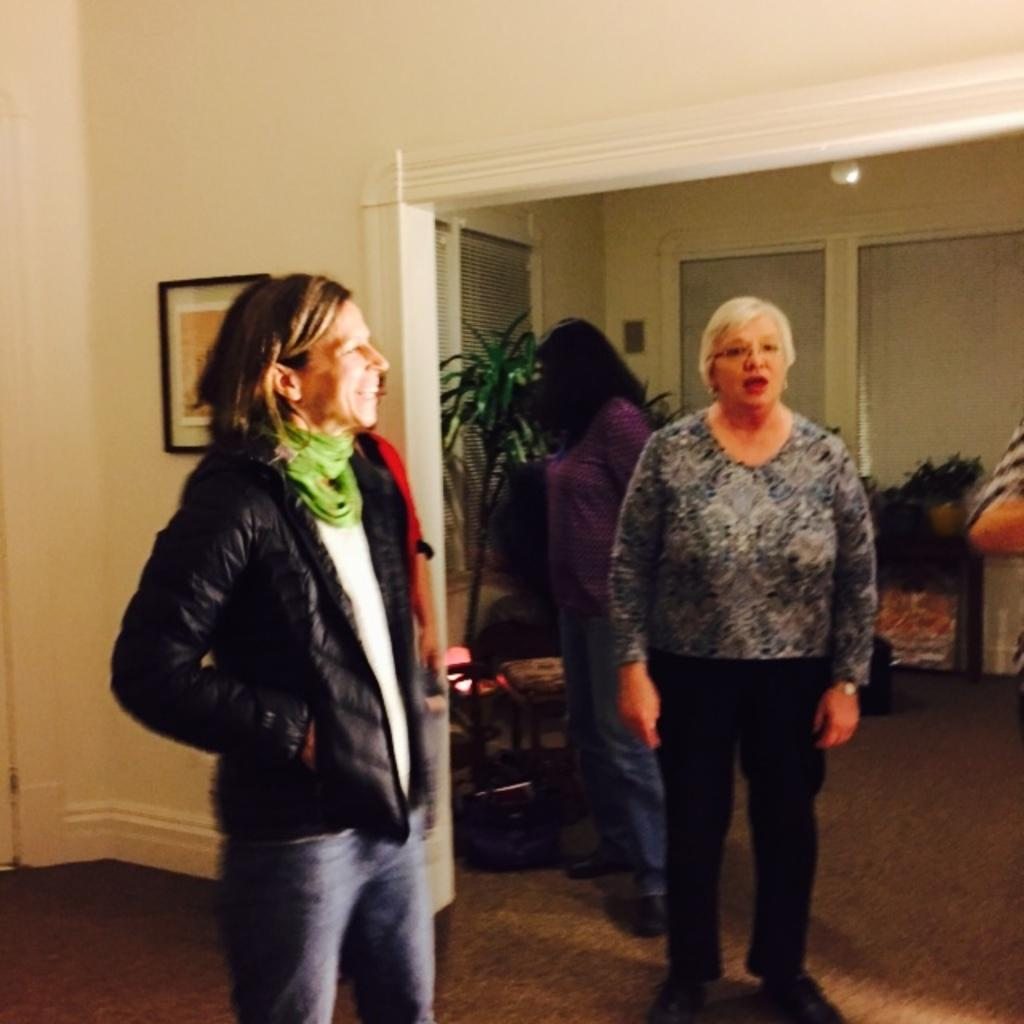What are the people in the image doing? There are people on the floor in the image. Can you describe the facial expression of one of the people? One person is smiling. What can be seen in the background of the image? There is a wall, a photo frame, plants, window shades, and some objects in the background of the image. What type of hammer is being used by the person in the image? There is no hammer present in the image; the people are on the floor, and no tools or instruments are visible. 